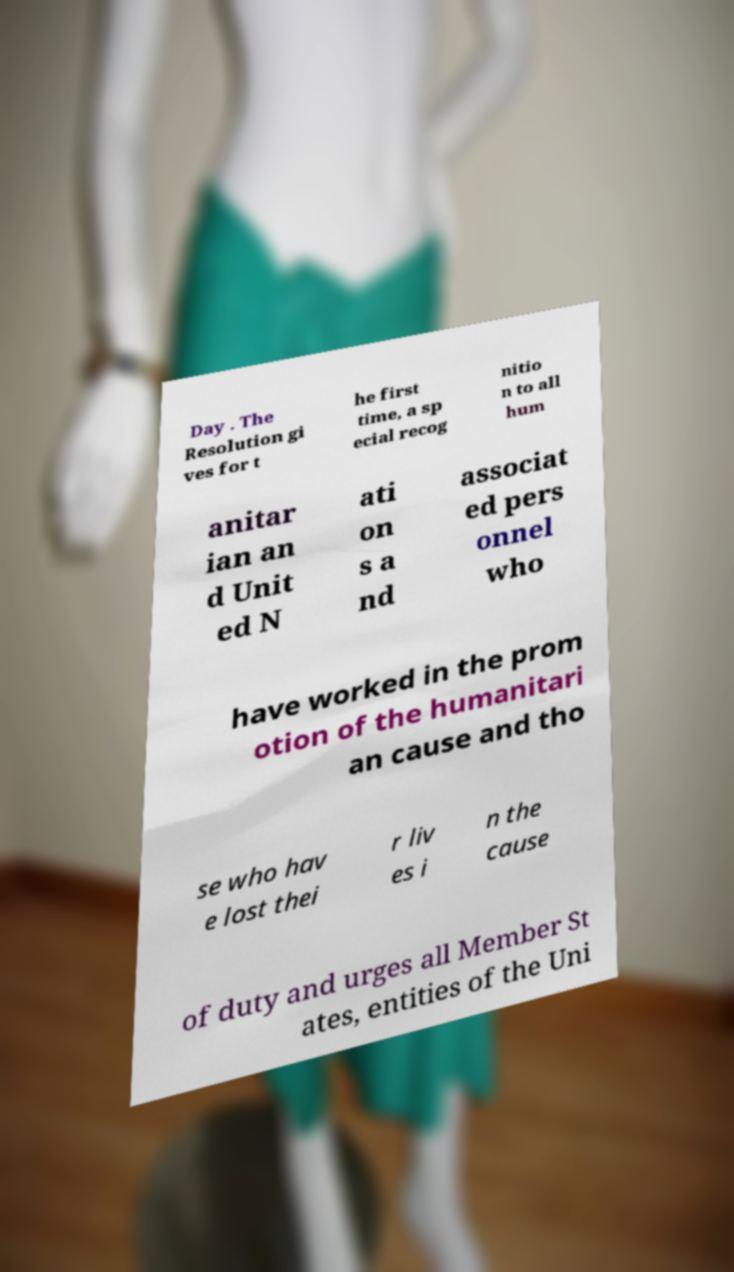Could you assist in decoding the text presented in this image and type it out clearly? Day . The Resolution gi ves for t he first time, a sp ecial recog nitio n to all hum anitar ian an d Unit ed N ati on s a nd associat ed pers onnel who have worked in the prom otion of the humanitari an cause and tho se who hav e lost thei r liv es i n the cause of duty and urges all Member St ates, entities of the Uni 